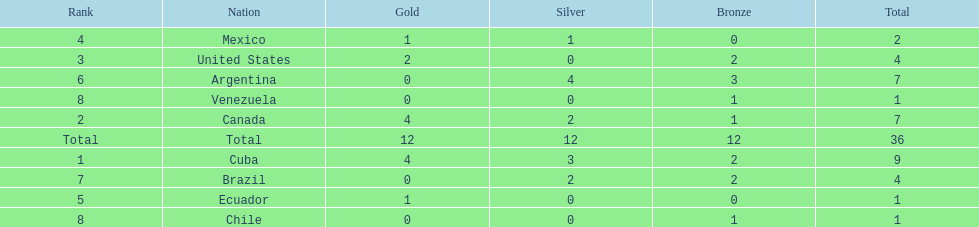Which country won the largest haul of bronze medals? Argentina. Write the full table. {'header': ['Rank', 'Nation', 'Gold', 'Silver', 'Bronze', 'Total'], 'rows': [['4', 'Mexico', '1', '1', '0', '2'], ['3', 'United States', '2', '0', '2', '4'], ['6', 'Argentina', '0', '4', '3', '7'], ['8', 'Venezuela', '0', '0', '1', '1'], ['2', 'Canada', '4', '2', '1', '7'], ['Total', 'Total', '12', '12', '12', '36'], ['1', 'Cuba', '4', '3', '2', '9'], ['7', 'Brazil', '0', '2', '2', '4'], ['5', 'Ecuador', '1', '0', '0', '1'], ['8', 'Chile', '0', '0', '1', '1']]} 